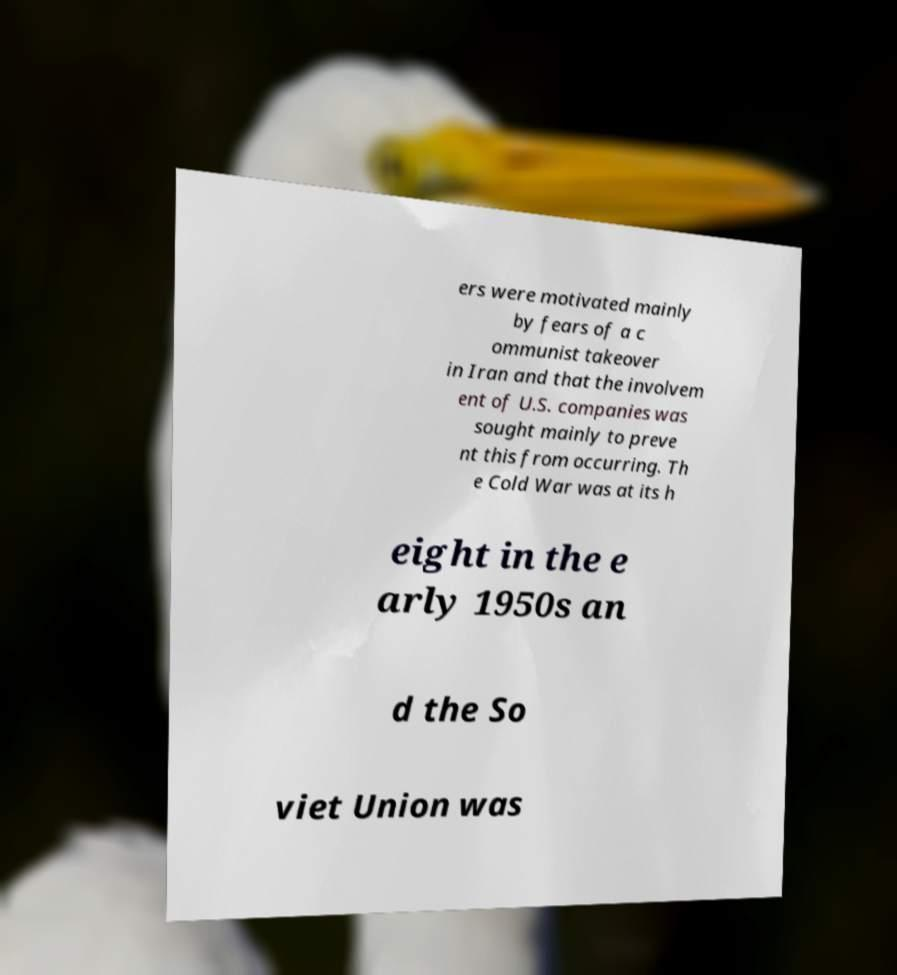I need the written content from this picture converted into text. Can you do that? ers were motivated mainly by fears of a c ommunist takeover in Iran and that the involvem ent of U.S. companies was sought mainly to preve nt this from occurring. Th e Cold War was at its h eight in the e arly 1950s an d the So viet Union was 